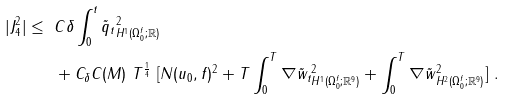<formula> <loc_0><loc_0><loc_500><loc_500>| J _ { 4 } ^ { 2 } | \leq \ & C \delta \int _ { 0 } ^ { t } \| \tilde { q } _ { t } \| ^ { 2 } _ { H ^ { 1 } ( \Omega _ { 0 } ^ { f } ; { \mathbb { R } } ) } \\ & + C _ { \delta } C ( M ) \ T ^ { \frac { 1 } { 4 } } \ [ N ( u _ { 0 } , f ) ^ { 2 } + T \int _ { 0 } ^ { T } \| \nabla \tilde { w } _ { t } \| ^ { 2 } _ { H ^ { 1 } ( \Omega _ { 0 } ^ { f } ; { \mathbb { R } } ^ { 9 } ) } + \int _ { 0 } ^ { T } \| \nabla \tilde { w } \| ^ { 2 } _ { H ^ { 2 } ( \Omega _ { 0 } ^ { f } ; { \mathbb { R } } ^ { 9 } ) } ] \ .</formula> 